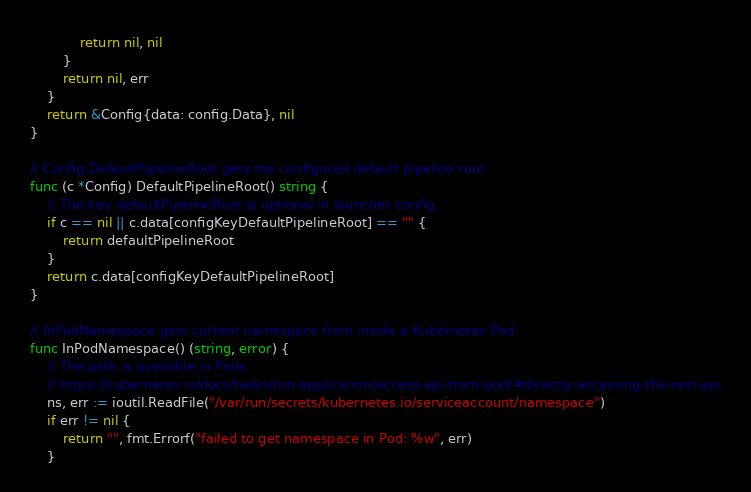Convert code to text. <code><loc_0><loc_0><loc_500><loc_500><_Go_>			return nil, nil
		}
		return nil, err
	}
	return &Config{data: config.Data}, nil
}

// Config.DefaultPipelineRoot gets the configured default pipeline root.
func (c *Config) DefaultPipelineRoot() string {
	// The key defaultPipelineRoot is optional in launcher config.
	if c == nil || c.data[configKeyDefaultPipelineRoot] == "" {
		return defaultPipelineRoot
	}
	return c.data[configKeyDefaultPipelineRoot]
}

// InPodNamespace gets current namespace from inside a Kubernetes Pod.
func InPodNamespace() (string, error) {
	// The path is available in Pods.
	// https://kubernetes.io/docs/tasks/run-application/access-api-from-pod/#directly-accessing-the-rest-api
	ns, err := ioutil.ReadFile("/var/run/secrets/kubernetes.io/serviceaccount/namespace")
	if err != nil {
		return "", fmt.Errorf("failed to get namespace in Pod: %w", err)
	}</code> 